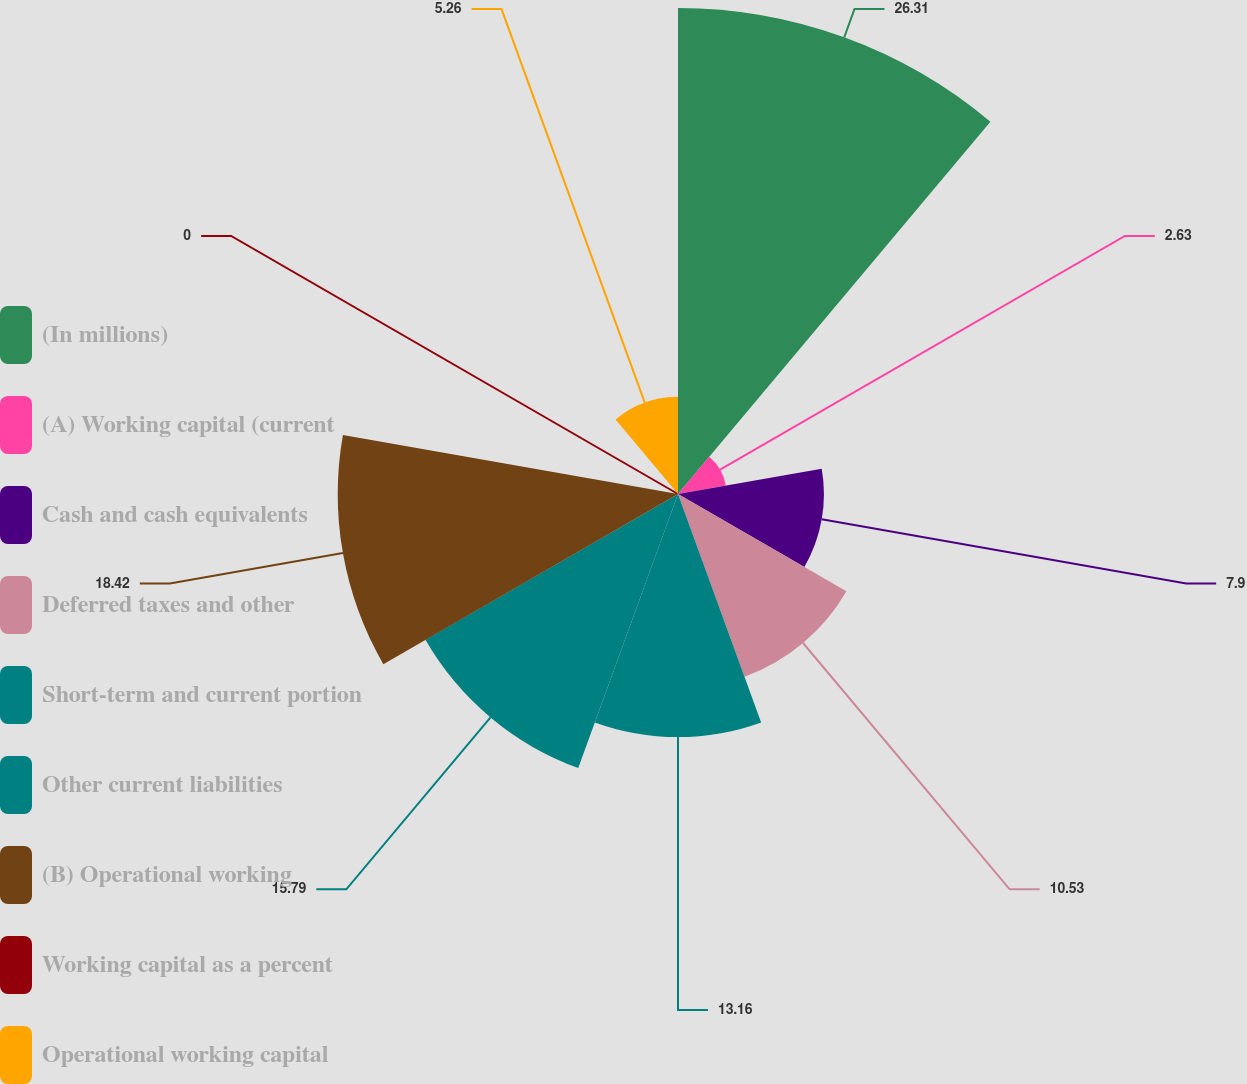Convert chart to OTSL. <chart><loc_0><loc_0><loc_500><loc_500><pie_chart><fcel>(In millions)<fcel>(A) Working capital (current<fcel>Cash and cash equivalents<fcel>Deferred taxes and other<fcel>Short-term and current portion<fcel>Other current liabilities<fcel>(B) Operational working<fcel>Working capital as a percent<fcel>Operational working capital<nl><fcel>26.31%<fcel>2.63%<fcel>7.9%<fcel>10.53%<fcel>13.16%<fcel>15.79%<fcel>18.42%<fcel>0.0%<fcel>5.26%<nl></chart> 